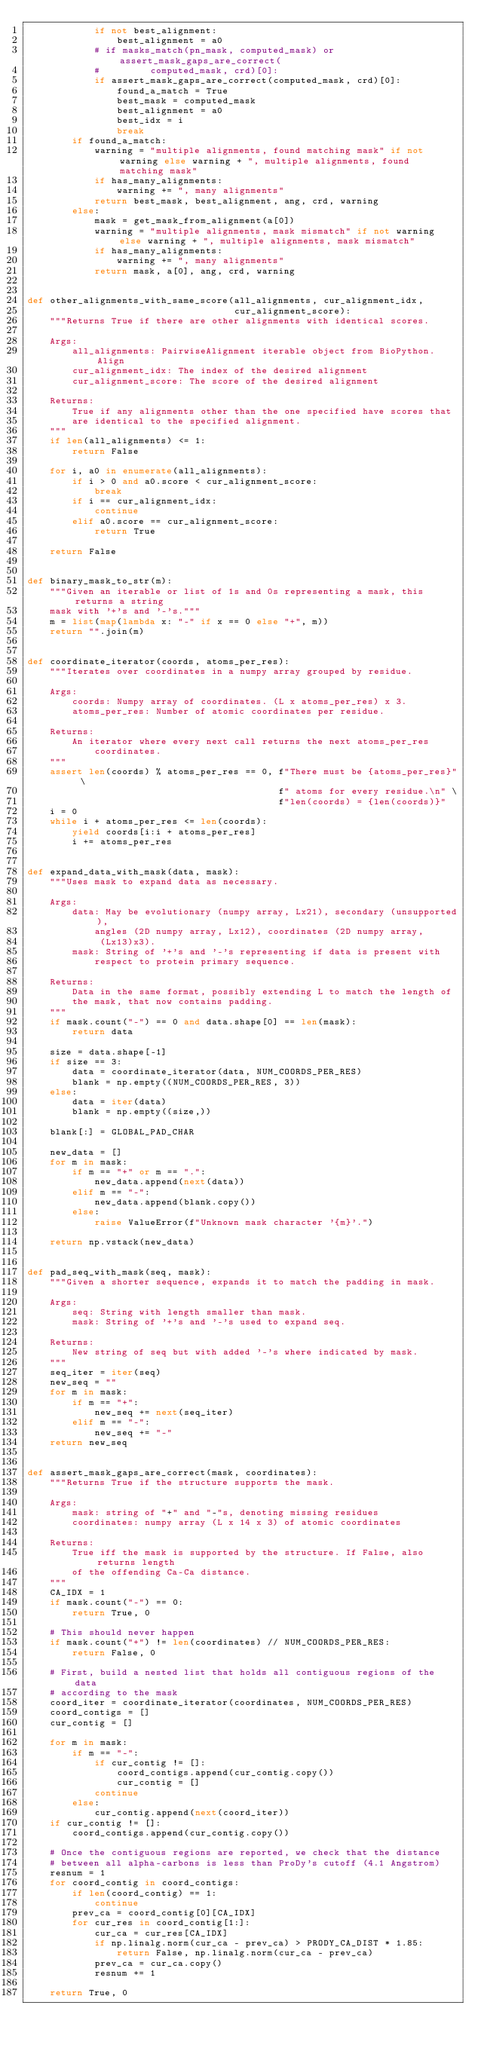<code> <loc_0><loc_0><loc_500><loc_500><_Python_>            if not best_alignment:
                best_alignment = a0
            # if masks_match(pn_mask, computed_mask) or assert_mask_gaps_are_correct(
            #         computed_mask, crd)[0]:
            if assert_mask_gaps_are_correct(computed_mask, crd)[0]:
                found_a_match = True
                best_mask = computed_mask
                best_alignment = a0
                best_idx = i
                break
        if found_a_match:
            warning = "multiple alignments, found matching mask" if not warning else warning + ", multiple alignments, found matching mask"
            if has_many_alignments:
                warning += ", many alignments"
            return best_mask, best_alignment, ang, crd, warning
        else:
            mask = get_mask_from_alignment(a[0])
            warning = "multiple alignments, mask mismatch" if not warning else warning + ", multiple alignments, mask mismatch"
            if has_many_alignments:
                warning += ", many alignments"
            return mask, a[0], ang, crd, warning


def other_alignments_with_same_score(all_alignments, cur_alignment_idx,
                                     cur_alignment_score):
    """Returns True if there are other alignments with identical scores.

    Args:
        all_alignments: PairwiseAlignment iterable object from BioPython.Align
        cur_alignment_idx: The index of the desired alignment
        cur_alignment_score: The score of the desired alignment

    Returns:
        True if any alignments other than the one specified have scores that
        are identical to the specified alignment.
    """
    if len(all_alignments) <= 1:
        return False

    for i, a0 in enumerate(all_alignments):
        if i > 0 and a0.score < cur_alignment_score:
            break
        if i == cur_alignment_idx:
            continue
        elif a0.score == cur_alignment_score:
            return True

    return False


def binary_mask_to_str(m):
    """Given an iterable or list of 1s and 0s representing a mask, this returns a string
    mask with '+'s and '-'s."""
    m = list(map(lambda x: "-" if x == 0 else "+", m))
    return "".join(m)


def coordinate_iterator(coords, atoms_per_res):
    """Iterates over coordinates in a numpy array grouped by residue.

    Args:
        coords: Numpy array of coordinates. (L x atoms_per_res) x 3.
        atoms_per_res: Number of atomic coordinates per residue.

    Returns:
        An iterator where every next call returns the next atoms_per_res
            coordinates.
    """
    assert len(coords) % atoms_per_res == 0, f"There must be {atoms_per_res}" \
                                             f" atoms for every residue.\n" \
                                             f"len(coords) = {len(coords)}"
    i = 0
    while i + atoms_per_res <= len(coords):
        yield coords[i:i + atoms_per_res]
        i += atoms_per_res


def expand_data_with_mask(data, mask):
    """Uses mask to expand data as necessary.

    Args:
        data: May be evolutionary (numpy array, Lx21), secondary (unsupported),
            angles (2D numpy array, Lx12), coordinates (2D numpy array,
             (Lx13)x3).
        mask: String of '+'s and '-'s representing if data is present with
            respect to protein primary sequence.

    Returns:
        Data in the same format, possibly extending L to match the length of
        the mask, that now contains padding.
    """
    if mask.count("-") == 0 and data.shape[0] == len(mask):
        return data

    size = data.shape[-1]
    if size == 3:
        data = coordinate_iterator(data, NUM_COORDS_PER_RES)
        blank = np.empty((NUM_COORDS_PER_RES, 3))
    else:
        data = iter(data)
        blank = np.empty((size,))

    blank[:] = GLOBAL_PAD_CHAR

    new_data = []
    for m in mask:
        if m == "+" or m == ".":
            new_data.append(next(data))
        elif m == "-":
            new_data.append(blank.copy())
        else:
            raise ValueError(f"Unknown mask character '{m}'.")

    return np.vstack(new_data)


def pad_seq_with_mask(seq, mask):
    """Given a shorter sequence, expands it to match the padding in mask.

    Args:
        seq: String with length smaller than mask.
        mask: String of '+'s and '-'s used to expand seq.

    Returns:
        New string of seq but with added '-'s where indicated by mask.
    """
    seq_iter = iter(seq)
    new_seq = ""
    for m in mask:
        if m == "+":
            new_seq += next(seq_iter)
        elif m == "-":
            new_seq += "-"
    return new_seq


def assert_mask_gaps_are_correct(mask, coordinates):
    """Returns True if the structure supports the mask.

    Args:
        mask: string of "+" and "-"s, denoting missing residues
        coordinates: numpy array (L x 14 x 3) of atomic coordinates

    Returns:
        True iff the mask is supported by the structure. If False, also returns length
        of the offending Ca-Ca distance.
    """
    CA_IDX = 1
    if mask.count("-") == 0:
        return True, 0

    # This should never happen
    if mask.count("+") != len(coordinates) // NUM_COORDS_PER_RES:
        return False, 0

    # First, build a nested list that holds all contiguous regions of the data
    # according to the mask
    coord_iter = coordinate_iterator(coordinates, NUM_COORDS_PER_RES)
    coord_contigs = []
    cur_contig = []

    for m in mask:
        if m == "-":
            if cur_contig != []:
                coord_contigs.append(cur_contig.copy())
                cur_contig = []
            continue
        else:
            cur_contig.append(next(coord_iter))
    if cur_contig != []:
        coord_contigs.append(cur_contig.copy())

    # Once the contiguous regions are reported, we check that the distance
    # between all alpha-carbons is less than ProDy's cutoff (4.1 Angstrom)
    resnum = 1
    for coord_contig in coord_contigs:
        if len(coord_contig) == 1:
            continue
        prev_ca = coord_contig[0][CA_IDX]
        for cur_res in coord_contig[1:]:
            cur_ca = cur_res[CA_IDX]
            if np.linalg.norm(cur_ca - prev_ca) > PRODY_CA_DIST * 1.85:
                return False, np.linalg.norm(cur_ca - prev_ca)
            prev_ca = cur_ca.copy()
            resnum += 1

    return True, 0
</code> 